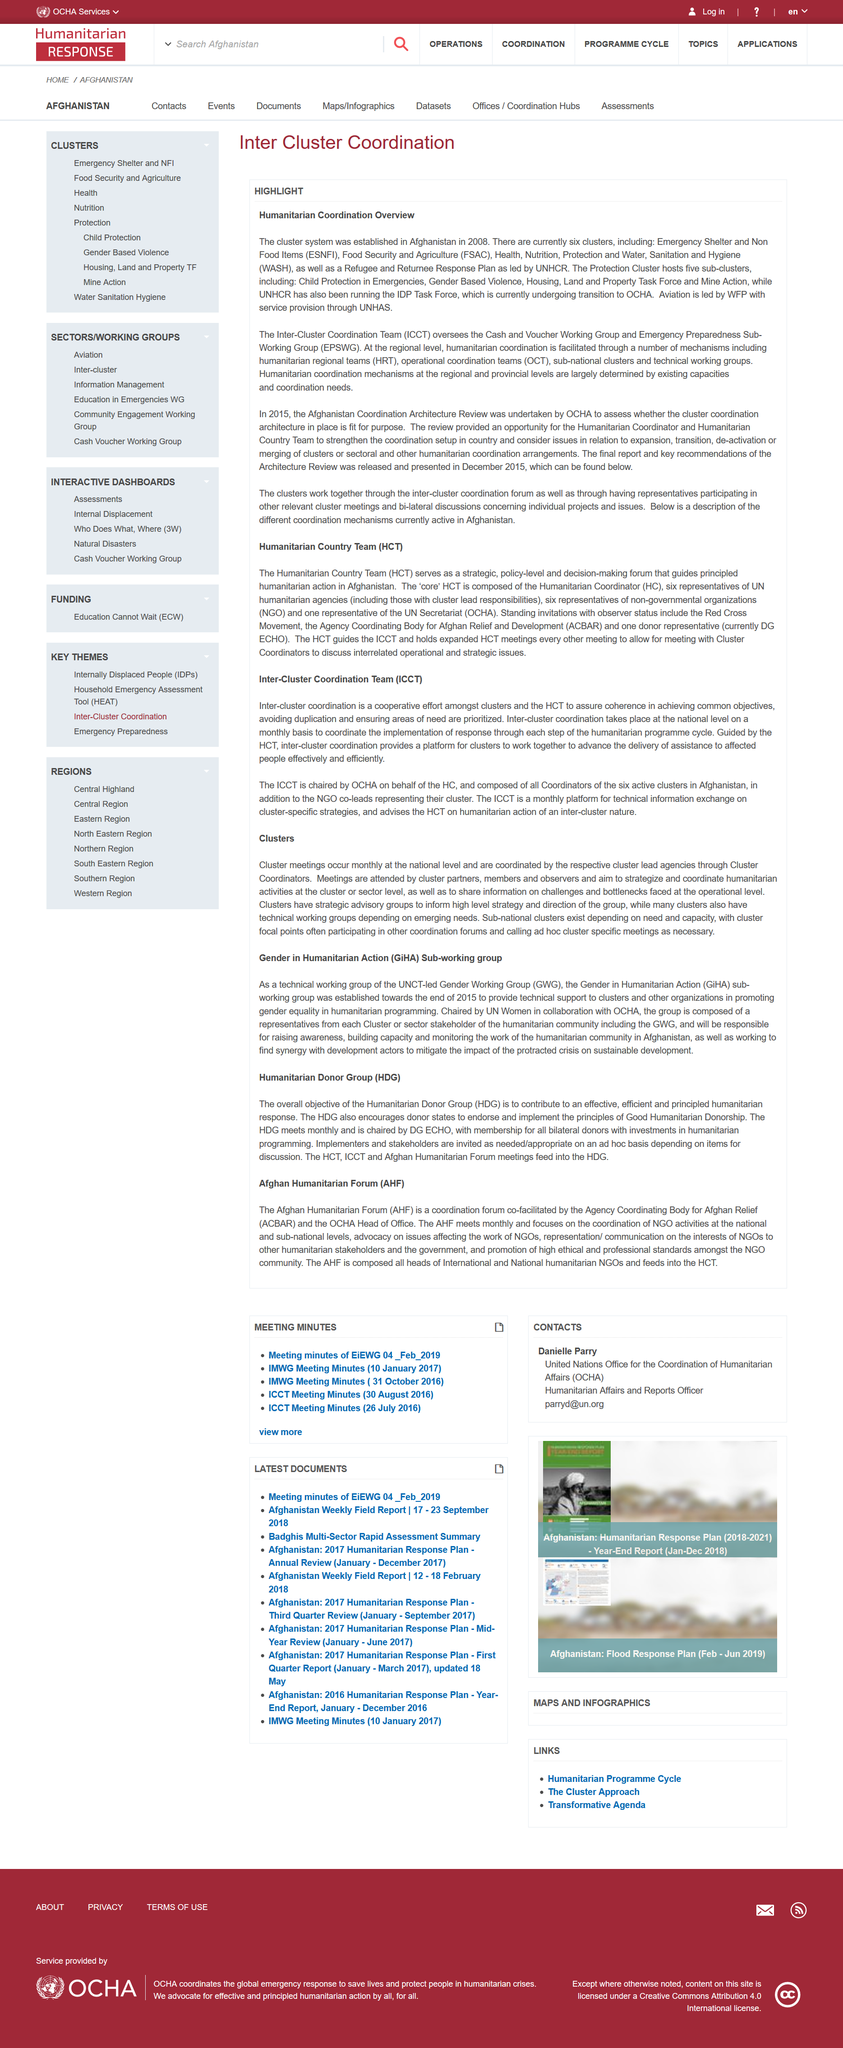Identify some key points in this picture. Humanitarian Regional Teams is an acronym that stands for a group of individuals who work together to provide aid and support to people in need, particularly in regional or remote areas. I am informing you that the acronym OCT stands for operational coordination teams. It is a term used to describe a group of individuals who work together to coordinate and manage various operational activities. The establishment of the cluster system in Afghanistan in 2008 is a part of the humanitarian coordination overview. 